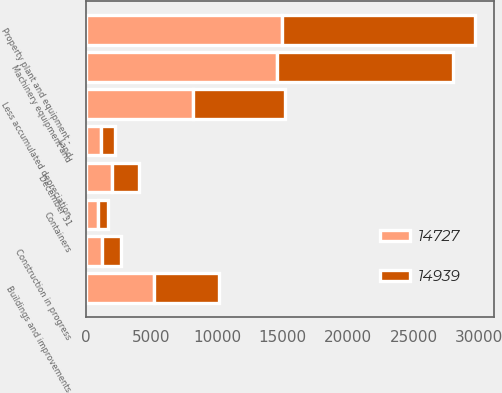<chart> <loc_0><loc_0><loc_500><loc_500><stacked_bar_chart><ecel><fcel>December 31<fcel>Land<fcel>Buildings and improvements<fcel>Machinery equipment and<fcel>Containers<fcel>Construction in progress<fcel>Less accumulated depreciation<fcel>Property plant and equipment -<nl><fcel>14727<fcel>2011<fcel>1141<fcel>5240<fcel>14609<fcel>895<fcel>1266<fcel>8212<fcel>14939<nl><fcel>14939<fcel>2010<fcel>1122<fcel>4883<fcel>13421<fcel>826<fcel>1454<fcel>6979<fcel>14727<nl></chart> 